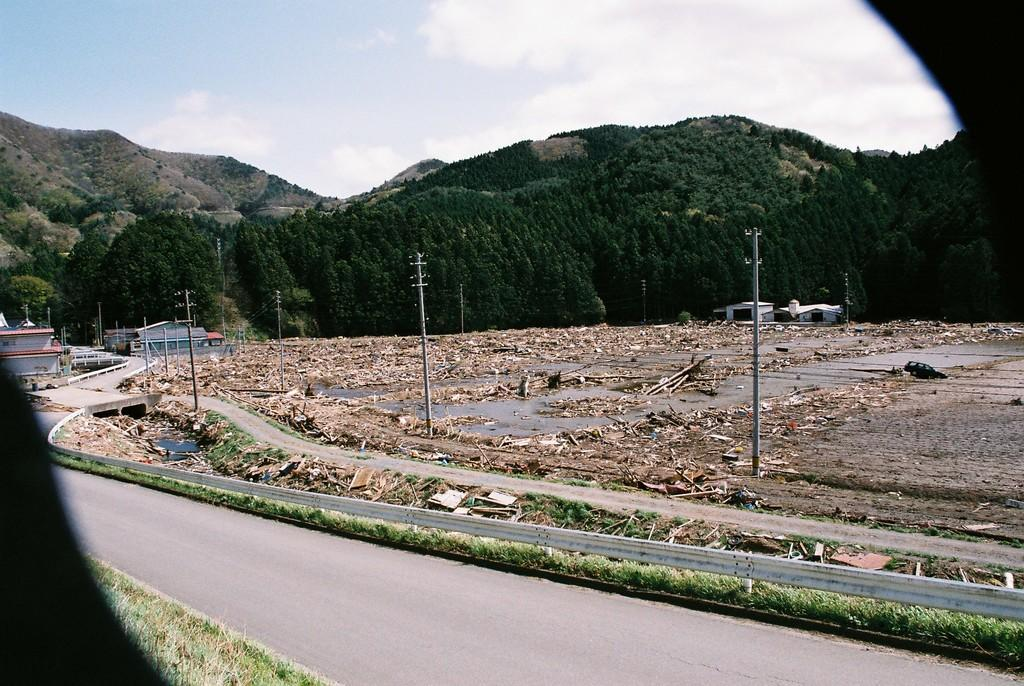What type of pathway is visible in the image? There is a road in the image. What structures can be seen along the road? There are poles visible in the image. What is located behind the poles? There is a group of objects visible behind the poles. What type of natural elements are present in the image? Trees and mountains are visible in the image. What type of residential structures are present in the image? Houses are present in the image. What is visible at the top of the image? The sky is visible at the top of the image. How many chickens are visible in the image? There are no chickens present in the image. What type of vessel is used to transport the houses in the image? There is no vessel present in the image, and the houses are stationary structures. 